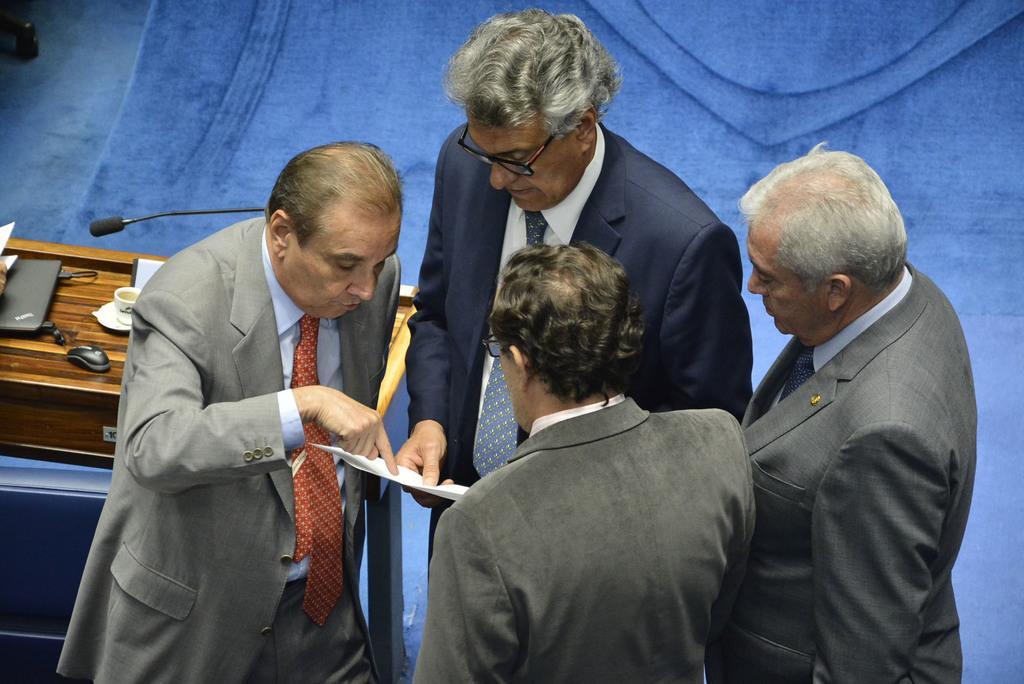In one or two sentences, can you explain what this image depicts? This image consists of 4 persons. All of them are wearing blazers. There is a podium on the left side and on that there is a laptop, mouse, mic, cup. 